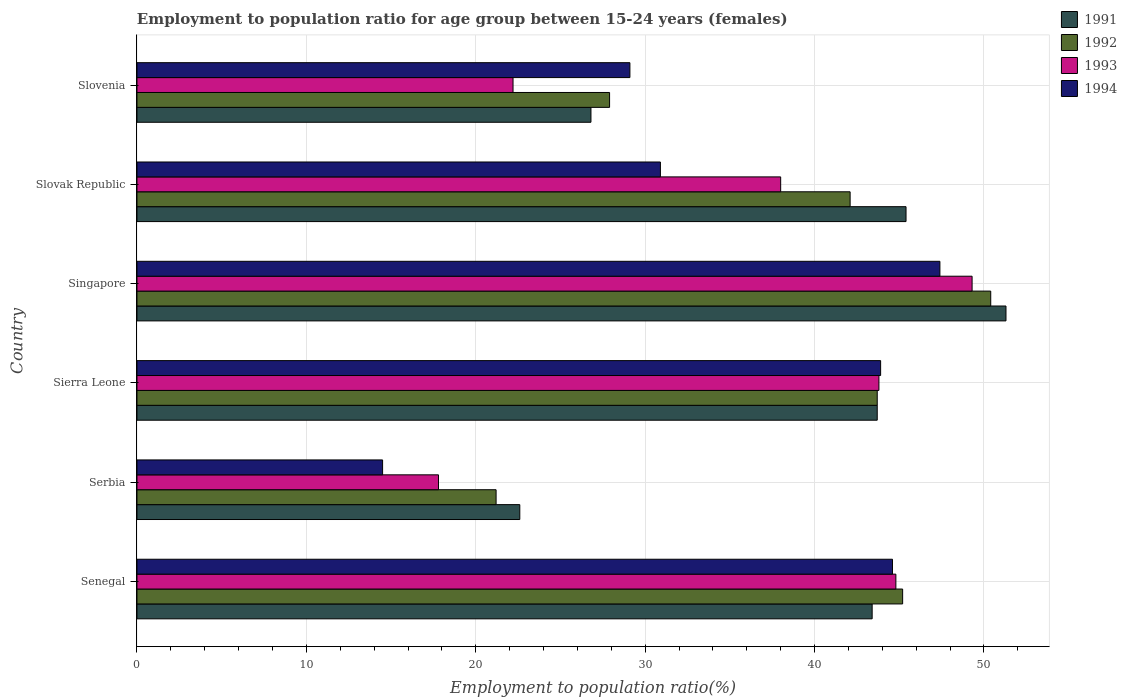How many different coloured bars are there?
Provide a short and direct response. 4. How many groups of bars are there?
Ensure brevity in your answer.  6. How many bars are there on the 1st tick from the top?
Offer a very short reply. 4. What is the label of the 4th group of bars from the top?
Offer a very short reply. Sierra Leone. In how many cases, is the number of bars for a given country not equal to the number of legend labels?
Make the answer very short. 0. What is the employment to population ratio in 1993 in Singapore?
Provide a succinct answer. 49.3. Across all countries, what is the maximum employment to population ratio in 1991?
Your response must be concise. 51.3. Across all countries, what is the minimum employment to population ratio in 1991?
Your answer should be very brief. 22.6. In which country was the employment to population ratio in 1994 maximum?
Offer a very short reply. Singapore. In which country was the employment to population ratio in 1992 minimum?
Offer a terse response. Serbia. What is the total employment to population ratio in 1993 in the graph?
Make the answer very short. 215.9. What is the difference between the employment to population ratio in 1991 in Senegal and that in Serbia?
Offer a very short reply. 20.8. What is the difference between the employment to population ratio in 1992 in Slovenia and the employment to population ratio in 1994 in Slovak Republic?
Keep it short and to the point. -3. What is the average employment to population ratio in 1993 per country?
Give a very brief answer. 35.98. What is the difference between the employment to population ratio in 1994 and employment to population ratio in 1992 in Sierra Leone?
Offer a very short reply. 0.2. In how many countries, is the employment to population ratio in 1991 greater than 16 %?
Give a very brief answer. 6. What is the ratio of the employment to population ratio in 1993 in Senegal to that in Slovak Republic?
Provide a succinct answer. 1.18. What is the difference between the highest and the lowest employment to population ratio in 1994?
Your answer should be very brief. 32.9. In how many countries, is the employment to population ratio in 1991 greater than the average employment to population ratio in 1991 taken over all countries?
Make the answer very short. 4. What does the 1st bar from the top in Slovenia represents?
Give a very brief answer. 1994. What does the 1st bar from the bottom in Slovak Republic represents?
Offer a very short reply. 1991. How many countries are there in the graph?
Ensure brevity in your answer.  6. Are the values on the major ticks of X-axis written in scientific E-notation?
Your response must be concise. No. Does the graph contain grids?
Your answer should be compact. Yes. Where does the legend appear in the graph?
Your answer should be very brief. Top right. What is the title of the graph?
Make the answer very short. Employment to population ratio for age group between 15-24 years (females). What is the label or title of the Y-axis?
Give a very brief answer. Country. What is the Employment to population ratio(%) of 1991 in Senegal?
Ensure brevity in your answer.  43.4. What is the Employment to population ratio(%) in 1992 in Senegal?
Keep it short and to the point. 45.2. What is the Employment to population ratio(%) in 1993 in Senegal?
Offer a very short reply. 44.8. What is the Employment to population ratio(%) of 1994 in Senegal?
Offer a terse response. 44.6. What is the Employment to population ratio(%) in 1991 in Serbia?
Offer a very short reply. 22.6. What is the Employment to population ratio(%) in 1992 in Serbia?
Make the answer very short. 21.2. What is the Employment to population ratio(%) of 1993 in Serbia?
Ensure brevity in your answer.  17.8. What is the Employment to population ratio(%) in 1991 in Sierra Leone?
Provide a short and direct response. 43.7. What is the Employment to population ratio(%) of 1992 in Sierra Leone?
Offer a terse response. 43.7. What is the Employment to population ratio(%) in 1993 in Sierra Leone?
Keep it short and to the point. 43.8. What is the Employment to population ratio(%) of 1994 in Sierra Leone?
Offer a very short reply. 43.9. What is the Employment to population ratio(%) of 1991 in Singapore?
Your answer should be very brief. 51.3. What is the Employment to population ratio(%) of 1992 in Singapore?
Provide a succinct answer. 50.4. What is the Employment to population ratio(%) in 1993 in Singapore?
Your answer should be compact. 49.3. What is the Employment to population ratio(%) of 1994 in Singapore?
Your response must be concise. 47.4. What is the Employment to population ratio(%) of 1991 in Slovak Republic?
Provide a succinct answer. 45.4. What is the Employment to population ratio(%) of 1992 in Slovak Republic?
Offer a very short reply. 42.1. What is the Employment to population ratio(%) of 1994 in Slovak Republic?
Keep it short and to the point. 30.9. What is the Employment to population ratio(%) of 1991 in Slovenia?
Your answer should be compact. 26.8. What is the Employment to population ratio(%) of 1992 in Slovenia?
Your answer should be very brief. 27.9. What is the Employment to population ratio(%) in 1993 in Slovenia?
Your answer should be compact. 22.2. What is the Employment to population ratio(%) in 1994 in Slovenia?
Ensure brevity in your answer.  29.1. Across all countries, what is the maximum Employment to population ratio(%) of 1991?
Offer a terse response. 51.3. Across all countries, what is the maximum Employment to population ratio(%) of 1992?
Provide a succinct answer. 50.4. Across all countries, what is the maximum Employment to population ratio(%) of 1993?
Make the answer very short. 49.3. Across all countries, what is the maximum Employment to population ratio(%) of 1994?
Ensure brevity in your answer.  47.4. Across all countries, what is the minimum Employment to population ratio(%) of 1991?
Your response must be concise. 22.6. Across all countries, what is the minimum Employment to population ratio(%) of 1992?
Your answer should be very brief. 21.2. Across all countries, what is the minimum Employment to population ratio(%) in 1993?
Your response must be concise. 17.8. Across all countries, what is the minimum Employment to population ratio(%) of 1994?
Give a very brief answer. 14.5. What is the total Employment to population ratio(%) in 1991 in the graph?
Your response must be concise. 233.2. What is the total Employment to population ratio(%) in 1992 in the graph?
Provide a short and direct response. 230.5. What is the total Employment to population ratio(%) of 1993 in the graph?
Make the answer very short. 215.9. What is the total Employment to population ratio(%) in 1994 in the graph?
Provide a succinct answer. 210.4. What is the difference between the Employment to population ratio(%) of 1991 in Senegal and that in Serbia?
Your answer should be very brief. 20.8. What is the difference between the Employment to population ratio(%) of 1994 in Senegal and that in Serbia?
Provide a short and direct response. 30.1. What is the difference between the Employment to population ratio(%) in 1991 in Senegal and that in Sierra Leone?
Give a very brief answer. -0.3. What is the difference between the Employment to population ratio(%) in 1992 in Senegal and that in Sierra Leone?
Make the answer very short. 1.5. What is the difference between the Employment to population ratio(%) in 1993 in Senegal and that in Sierra Leone?
Offer a terse response. 1. What is the difference between the Employment to population ratio(%) of 1994 in Senegal and that in Sierra Leone?
Ensure brevity in your answer.  0.7. What is the difference between the Employment to population ratio(%) of 1993 in Senegal and that in Singapore?
Your response must be concise. -4.5. What is the difference between the Employment to population ratio(%) of 1991 in Senegal and that in Slovak Republic?
Your response must be concise. -2. What is the difference between the Employment to population ratio(%) in 1994 in Senegal and that in Slovak Republic?
Provide a short and direct response. 13.7. What is the difference between the Employment to population ratio(%) in 1991 in Senegal and that in Slovenia?
Your response must be concise. 16.6. What is the difference between the Employment to population ratio(%) of 1993 in Senegal and that in Slovenia?
Provide a short and direct response. 22.6. What is the difference between the Employment to population ratio(%) of 1991 in Serbia and that in Sierra Leone?
Give a very brief answer. -21.1. What is the difference between the Employment to population ratio(%) in 1992 in Serbia and that in Sierra Leone?
Offer a very short reply. -22.5. What is the difference between the Employment to population ratio(%) in 1994 in Serbia and that in Sierra Leone?
Ensure brevity in your answer.  -29.4. What is the difference between the Employment to population ratio(%) in 1991 in Serbia and that in Singapore?
Your answer should be compact. -28.7. What is the difference between the Employment to population ratio(%) of 1992 in Serbia and that in Singapore?
Your response must be concise. -29.2. What is the difference between the Employment to population ratio(%) of 1993 in Serbia and that in Singapore?
Give a very brief answer. -31.5. What is the difference between the Employment to population ratio(%) of 1994 in Serbia and that in Singapore?
Your answer should be very brief. -32.9. What is the difference between the Employment to population ratio(%) of 1991 in Serbia and that in Slovak Republic?
Offer a terse response. -22.8. What is the difference between the Employment to population ratio(%) in 1992 in Serbia and that in Slovak Republic?
Make the answer very short. -20.9. What is the difference between the Employment to population ratio(%) of 1993 in Serbia and that in Slovak Republic?
Offer a very short reply. -20.2. What is the difference between the Employment to population ratio(%) of 1994 in Serbia and that in Slovak Republic?
Make the answer very short. -16.4. What is the difference between the Employment to population ratio(%) of 1993 in Serbia and that in Slovenia?
Your answer should be compact. -4.4. What is the difference between the Employment to population ratio(%) of 1994 in Serbia and that in Slovenia?
Ensure brevity in your answer.  -14.6. What is the difference between the Employment to population ratio(%) of 1991 in Sierra Leone and that in Singapore?
Ensure brevity in your answer.  -7.6. What is the difference between the Employment to population ratio(%) of 1993 in Sierra Leone and that in Singapore?
Offer a terse response. -5.5. What is the difference between the Employment to population ratio(%) of 1992 in Sierra Leone and that in Slovak Republic?
Your answer should be compact. 1.6. What is the difference between the Employment to population ratio(%) in 1993 in Sierra Leone and that in Slovak Republic?
Your response must be concise. 5.8. What is the difference between the Employment to population ratio(%) of 1992 in Sierra Leone and that in Slovenia?
Your answer should be compact. 15.8. What is the difference between the Employment to population ratio(%) of 1993 in Sierra Leone and that in Slovenia?
Offer a very short reply. 21.6. What is the difference between the Employment to population ratio(%) in 1991 in Singapore and that in Slovak Republic?
Offer a very short reply. 5.9. What is the difference between the Employment to population ratio(%) in 1994 in Singapore and that in Slovak Republic?
Ensure brevity in your answer.  16.5. What is the difference between the Employment to population ratio(%) of 1993 in Singapore and that in Slovenia?
Ensure brevity in your answer.  27.1. What is the difference between the Employment to population ratio(%) in 1994 in Singapore and that in Slovenia?
Your answer should be compact. 18.3. What is the difference between the Employment to population ratio(%) in 1993 in Slovak Republic and that in Slovenia?
Give a very brief answer. 15.8. What is the difference between the Employment to population ratio(%) in 1991 in Senegal and the Employment to population ratio(%) in 1993 in Serbia?
Ensure brevity in your answer.  25.6. What is the difference between the Employment to population ratio(%) in 1991 in Senegal and the Employment to population ratio(%) in 1994 in Serbia?
Your answer should be compact. 28.9. What is the difference between the Employment to population ratio(%) in 1992 in Senegal and the Employment to population ratio(%) in 1993 in Serbia?
Your answer should be compact. 27.4. What is the difference between the Employment to population ratio(%) in 1992 in Senegal and the Employment to population ratio(%) in 1994 in Serbia?
Your response must be concise. 30.7. What is the difference between the Employment to population ratio(%) in 1993 in Senegal and the Employment to population ratio(%) in 1994 in Serbia?
Ensure brevity in your answer.  30.3. What is the difference between the Employment to population ratio(%) in 1992 in Senegal and the Employment to population ratio(%) in 1994 in Sierra Leone?
Provide a succinct answer. 1.3. What is the difference between the Employment to population ratio(%) of 1992 in Senegal and the Employment to population ratio(%) of 1993 in Singapore?
Your answer should be compact. -4.1. What is the difference between the Employment to population ratio(%) of 1993 in Senegal and the Employment to population ratio(%) of 1994 in Singapore?
Keep it short and to the point. -2.6. What is the difference between the Employment to population ratio(%) in 1991 in Senegal and the Employment to population ratio(%) in 1992 in Slovak Republic?
Provide a succinct answer. 1.3. What is the difference between the Employment to population ratio(%) in 1991 in Senegal and the Employment to population ratio(%) in 1994 in Slovak Republic?
Provide a succinct answer. 12.5. What is the difference between the Employment to population ratio(%) in 1991 in Senegal and the Employment to population ratio(%) in 1993 in Slovenia?
Your answer should be very brief. 21.2. What is the difference between the Employment to population ratio(%) in 1991 in Senegal and the Employment to population ratio(%) in 1994 in Slovenia?
Provide a short and direct response. 14.3. What is the difference between the Employment to population ratio(%) in 1992 in Senegal and the Employment to population ratio(%) in 1993 in Slovenia?
Your answer should be compact. 23. What is the difference between the Employment to population ratio(%) in 1992 in Senegal and the Employment to population ratio(%) in 1994 in Slovenia?
Your response must be concise. 16.1. What is the difference between the Employment to population ratio(%) of 1991 in Serbia and the Employment to population ratio(%) of 1992 in Sierra Leone?
Provide a short and direct response. -21.1. What is the difference between the Employment to population ratio(%) in 1991 in Serbia and the Employment to population ratio(%) in 1993 in Sierra Leone?
Keep it short and to the point. -21.2. What is the difference between the Employment to population ratio(%) in 1991 in Serbia and the Employment to population ratio(%) in 1994 in Sierra Leone?
Keep it short and to the point. -21.3. What is the difference between the Employment to population ratio(%) of 1992 in Serbia and the Employment to population ratio(%) of 1993 in Sierra Leone?
Offer a very short reply. -22.6. What is the difference between the Employment to population ratio(%) of 1992 in Serbia and the Employment to population ratio(%) of 1994 in Sierra Leone?
Your response must be concise. -22.7. What is the difference between the Employment to population ratio(%) in 1993 in Serbia and the Employment to population ratio(%) in 1994 in Sierra Leone?
Your answer should be very brief. -26.1. What is the difference between the Employment to population ratio(%) of 1991 in Serbia and the Employment to population ratio(%) of 1992 in Singapore?
Offer a very short reply. -27.8. What is the difference between the Employment to population ratio(%) in 1991 in Serbia and the Employment to population ratio(%) in 1993 in Singapore?
Offer a very short reply. -26.7. What is the difference between the Employment to population ratio(%) of 1991 in Serbia and the Employment to population ratio(%) of 1994 in Singapore?
Provide a short and direct response. -24.8. What is the difference between the Employment to population ratio(%) of 1992 in Serbia and the Employment to population ratio(%) of 1993 in Singapore?
Make the answer very short. -28.1. What is the difference between the Employment to population ratio(%) of 1992 in Serbia and the Employment to population ratio(%) of 1994 in Singapore?
Your answer should be very brief. -26.2. What is the difference between the Employment to population ratio(%) of 1993 in Serbia and the Employment to population ratio(%) of 1994 in Singapore?
Your answer should be very brief. -29.6. What is the difference between the Employment to population ratio(%) in 1991 in Serbia and the Employment to population ratio(%) in 1992 in Slovak Republic?
Offer a very short reply. -19.5. What is the difference between the Employment to population ratio(%) of 1991 in Serbia and the Employment to population ratio(%) of 1993 in Slovak Republic?
Provide a succinct answer. -15.4. What is the difference between the Employment to population ratio(%) in 1991 in Serbia and the Employment to population ratio(%) in 1994 in Slovak Republic?
Your answer should be compact. -8.3. What is the difference between the Employment to population ratio(%) in 1992 in Serbia and the Employment to population ratio(%) in 1993 in Slovak Republic?
Offer a very short reply. -16.8. What is the difference between the Employment to population ratio(%) of 1992 in Serbia and the Employment to population ratio(%) of 1993 in Slovenia?
Make the answer very short. -1. What is the difference between the Employment to population ratio(%) of 1993 in Serbia and the Employment to population ratio(%) of 1994 in Slovenia?
Provide a short and direct response. -11.3. What is the difference between the Employment to population ratio(%) of 1991 in Sierra Leone and the Employment to population ratio(%) of 1992 in Singapore?
Offer a very short reply. -6.7. What is the difference between the Employment to population ratio(%) of 1992 in Sierra Leone and the Employment to population ratio(%) of 1993 in Singapore?
Offer a very short reply. -5.6. What is the difference between the Employment to population ratio(%) of 1993 in Sierra Leone and the Employment to population ratio(%) of 1994 in Singapore?
Offer a terse response. -3.6. What is the difference between the Employment to population ratio(%) in 1991 in Sierra Leone and the Employment to population ratio(%) in 1994 in Slovak Republic?
Give a very brief answer. 12.8. What is the difference between the Employment to population ratio(%) of 1991 in Sierra Leone and the Employment to population ratio(%) of 1994 in Slovenia?
Your answer should be compact. 14.6. What is the difference between the Employment to population ratio(%) in 1993 in Sierra Leone and the Employment to population ratio(%) in 1994 in Slovenia?
Offer a terse response. 14.7. What is the difference between the Employment to population ratio(%) of 1991 in Singapore and the Employment to population ratio(%) of 1993 in Slovak Republic?
Provide a short and direct response. 13.3. What is the difference between the Employment to population ratio(%) of 1991 in Singapore and the Employment to population ratio(%) of 1994 in Slovak Republic?
Provide a short and direct response. 20.4. What is the difference between the Employment to population ratio(%) in 1991 in Singapore and the Employment to population ratio(%) in 1992 in Slovenia?
Provide a short and direct response. 23.4. What is the difference between the Employment to population ratio(%) of 1991 in Singapore and the Employment to population ratio(%) of 1993 in Slovenia?
Make the answer very short. 29.1. What is the difference between the Employment to population ratio(%) in 1991 in Singapore and the Employment to population ratio(%) in 1994 in Slovenia?
Make the answer very short. 22.2. What is the difference between the Employment to population ratio(%) in 1992 in Singapore and the Employment to population ratio(%) in 1993 in Slovenia?
Make the answer very short. 28.2. What is the difference between the Employment to population ratio(%) of 1992 in Singapore and the Employment to population ratio(%) of 1994 in Slovenia?
Your answer should be very brief. 21.3. What is the difference between the Employment to population ratio(%) of 1993 in Singapore and the Employment to population ratio(%) of 1994 in Slovenia?
Provide a short and direct response. 20.2. What is the difference between the Employment to population ratio(%) of 1991 in Slovak Republic and the Employment to population ratio(%) of 1993 in Slovenia?
Offer a very short reply. 23.2. What is the difference between the Employment to population ratio(%) in 1992 in Slovak Republic and the Employment to population ratio(%) in 1993 in Slovenia?
Give a very brief answer. 19.9. What is the average Employment to population ratio(%) in 1991 per country?
Offer a very short reply. 38.87. What is the average Employment to population ratio(%) in 1992 per country?
Make the answer very short. 38.42. What is the average Employment to population ratio(%) in 1993 per country?
Provide a succinct answer. 35.98. What is the average Employment to population ratio(%) in 1994 per country?
Provide a short and direct response. 35.07. What is the difference between the Employment to population ratio(%) in 1991 and Employment to population ratio(%) in 1993 in Senegal?
Your response must be concise. -1.4. What is the difference between the Employment to population ratio(%) in 1991 and Employment to population ratio(%) in 1994 in Senegal?
Your answer should be compact. -1.2. What is the difference between the Employment to population ratio(%) of 1993 and Employment to population ratio(%) of 1994 in Senegal?
Give a very brief answer. 0.2. What is the difference between the Employment to population ratio(%) in 1991 and Employment to population ratio(%) in 1992 in Serbia?
Your answer should be compact. 1.4. What is the difference between the Employment to population ratio(%) of 1991 and Employment to population ratio(%) of 1993 in Serbia?
Provide a succinct answer. 4.8. What is the difference between the Employment to population ratio(%) of 1991 and Employment to population ratio(%) of 1994 in Serbia?
Your answer should be compact. 8.1. What is the difference between the Employment to population ratio(%) of 1992 and Employment to population ratio(%) of 1993 in Sierra Leone?
Keep it short and to the point. -0.1. What is the difference between the Employment to population ratio(%) in 1991 and Employment to population ratio(%) in 1994 in Singapore?
Ensure brevity in your answer.  3.9. What is the difference between the Employment to population ratio(%) of 1992 and Employment to population ratio(%) of 1993 in Singapore?
Give a very brief answer. 1.1. What is the difference between the Employment to population ratio(%) in 1992 and Employment to population ratio(%) in 1994 in Singapore?
Your response must be concise. 3. What is the difference between the Employment to population ratio(%) in 1991 and Employment to population ratio(%) in 1992 in Slovak Republic?
Keep it short and to the point. 3.3. What is the difference between the Employment to population ratio(%) of 1992 and Employment to population ratio(%) of 1993 in Slovak Republic?
Give a very brief answer. 4.1. What is the difference between the Employment to population ratio(%) of 1992 and Employment to population ratio(%) of 1994 in Slovak Republic?
Offer a very short reply. 11.2. What is the difference between the Employment to population ratio(%) of 1993 and Employment to population ratio(%) of 1994 in Slovak Republic?
Keep it short and to the point. 7.1. What is the difference between the Employment to population ratio(%) in 1991 and Employment to population ratio(%) in 1992 in Slovenia?
Your response must be concise. -1.1. What is the difference between the Employment to population ratio(%) of 1991 and Employment to population ratio(%) of 1994 in Slovenia?
Offer a very short reply. -2.3. What is the difference between the Employment to population ratio(%) in 1993 and Employment to population ratio(%) in 1994 in Slovenia?
Your answer should be very brief. -6.9. What is the ratio of the Employment to population ratio(%) in 1991 in Senegal to that in Serbia?
Your response must be concise. 1.92. What is the ratio of the Employment to population ratio(%) in 1992 in Senegal to that in Serbia?
Your response must be concise. 2.13. What is the ratio of the Employment to population ratio(%) of 1993 in Senegal to that in Serbia?
Provide a succinct answer. 2.52. What is the ratio of the Employment to population ratio(%) of 1994 in Senegal to that in Serbia?
Offer a very short reply. 3.08. What is the ratio of the Employment to population ratio(%) in 1992 in Senegal to that in Sierra Leone?
Ensure brevity in your answer.  1.03. What is the ratio of the Employment to population ratio(%) of 1993 in Senegal to that in Sierra Leone?
Make the answer very short. 1.02. What is the ratio of the Employment to population ratio(%) of 1994 in Senegal to that in Sierra Leone?
Make the answer very short. 1.02. What is the ratio of the Employment to population ratio(%) of 1991 in Senegal to that in Singapore?
Your answer should be very brief. 0.85. What is the ratio of the Employment to population ratio(%) in 1992 in Senegal to that in Singapore?
Make the answer very short. 0.9. What is the ratio of the Employment to population ratio(%) in 1993 in Senegal to that in Singapore?
Your answer should be very brief. 0.91. What is the ratio of the Employment to population ratio(%) in 1994 in Senegal to that in Singapore?
Your answer should be compact. 0.94. What is the ratio of the Employment to population ratio(%) of 1991 in Senegal to that in Slovak Republic?
Provide a short and direct response. 0.96. What is the ratio of the Employment to population ratio(%) of 1992 in Senegal to that in Slovak Republic?
Keep it short and to the point. 1.07. What is the ratio of the Employment to population ratio(%) of 1993 in Senegal to that in Slovak Republic?
Offer a very short reply. 1.18. What is the ratio of the Employment to population ratio(%) in 1994 in Senegal to that in Slovak Republic?
Ensure brevity in your answer.  1.44. What is the ratio of the Employment to population ratio(%) in 1991 in Senegal to that in Slovenia?
Ensure brevity in your answer.  1.62. What is the ratio of the Employment to population ratio(%) of 1992 in Senegal to that in Slovenia?
Ensure brevity in your answer.  1.62. What is the ratio of the Employment to population ratio(%) of 1993 in Senegal to that in Slovenia?
Offer a very short reply. 2.02. What is the ratio of the Employment to population ratio(%) in 1994 in Senegal to that in Slovenia?
Offer a terse response. 1.53. What is the ratio of the Employment to population ratio(%) of 1991 in Serbia to that in Sierra Leone?
Offer a very short reply. 0.52. What is the ratio of the Employment to population ratio(%) in 1992 in Serbia to that in Sierra Leone?
Your answer should be compact. 0.49. What is the ratio of the Employment to population ratio(%) in 1993 in Serbia to that in Sierra Leone?
Provide a succinct answer. 0.41. What is the ratio of the Employment to population ratio(%) of 1994 in Serbia to that in Sierra Leone?
Offer a terse response. 0.33. What is the ratio of the Employment to population ratio(%) in 1991 in Serbia to that in Singapore?
Offer a terse response. 0.44. What is the ratio of the Employment to population ratio(%) in 1992 in Serbia to that in Singapore?
Keep it short and to the point. 0.42. What is the ratio of the Employment to population ratio(%) of 1993 in Serbia to that in Singapore?
Offer a very short reply. 0.36. What is the ratio of the Employment to population ratio(%) in 1994 in Serbia to that in Singapore?
Offer a very short reply. 0.31. What is the ratio of the Employment to population ratio(%) in 1991 in Serbia to that in Slovak Republic?
Provide a short and direct response. 0.5. What is the ratio of the Employment to population ratio(%) of 1992 in Serbia to that in Slovak Republic?
Make the answer very short. 0.5. What is the ratio of the Employment to population ratio(%) in 1993 in Serbia to that in Slovak Republic?
Provide a succinct answer. 0.47. What is the ratio of the Employment to population ratio(%) of 1994 in Serbia to that in Slovak Republic?
Provide a succinct answer. 0.47. What is the ratio of the Employment to population ratio(%) of 1991 in Serbia to that in Slovenia?
Give a very brief answer. 0.84. What is the ratio of the Employment to population ratio(%) of 1992 in Serbia to that in Slovenia?
Provide a succinct answer. 0.76. What is the ratio of the Employment to population ratio(%) in 1993 in Serbia to that in Slovenia?
Your answer should be very brief. 0.8. What is the ratio of the Employment to population ratio(%) in 1994 in Serbia to that in Slovenia?
Provide a short and direct response. 0.5. What is the ratio of the Employment to population ratio(%) of 1991 in Sierra Leone to that in Singapore?
Offer a very short reply. 0.85. What is the ratio of the Employment to population ratio(%) of 1992 in Sierra Leone to that in Singapore?
Make the answer very short. 0.87. What is the ratio of the Employment to population ratio(%) in 1993 in Sierra Leone to that in Singapore?
Provide a succinct answer. 0.89. What is the ratio of the Employment to population ratio(%) of 1994 in Sierra Leone to that in Singapore?
Keep it short and to the point. 0.93. What is the ratio of the Employment to population ratio(%) in 1991 in Sierra Leone to that in Slovak Republic?
Give a very brief answer. 0.96. What is the ratio of the Employment to population ratio(%) in 1992 in Sierra Leone to that in Slovak Republic?
Ensure brevity in your answer.  1.04. What is the ratio of the Employment to population ratio(%) in 1993 in Sierra Leone to that in Slovak Republic?
Offer a very short reply. 1.15. What is the ratio of the Employment to population ratio(%) of 1994 in Sierra Leone to that in Slovak Republic?
Make the answer very short. 1.42. What is the ratio of the Employment to population ratio(%) in 1991 in Sierra Leone to that in Slovenia?
Offer a very short reply. 1.63. What is the ratio of the Employment to population ratio(%) in 1992 in Sierra Leone to that in Slovenia?
Your answer should be very brief. 1.57. What is the ratio of the Employment to population ratio(%) in 1993 in Sierra Leone to that in Slovenia?
Make the answer very short. 1.97. What is the ratio of the Employment to population ratio(%) in 1994 in Sierra Leone to that in Slovenia?
Ensure brevity in your answer.  1.51. What is the ratio of the Employment to population ratio(%) in 1991 in Singapore to that in Slovak Republic?
Offer a very short reply. 1.13. What is the ratio of the Employment to population ratio(%) in 1992 in Singapore to that in Slovak Republic?
Keep it short and to the point. 1.2. What is the ratio of the Employment to population ratio(%) in 1993 in Singapore to that in Slovak Republic?
Your answer should be very brief. 1.3. What is the ratio of the Employment to population ratio(%) in 1994 in Singapore to that in Slovak Republic?
Offer a terse response. 1.53. What is the ratio of the Employment to population ratio(%) in 1991 in Singapore to that in Slovenia?
Make the answer very short. 1.91. What is the ratio of the Employment to population ratio(%) in 1992 in Singapore to that in Slovenia?
Your answer should be very brief. 1.81. What is the ratio of the Employment to population ratio(%) of 1993 in Singapore to that in Slovenia?
Your response must be concise. 2.22. What is the ratio of the Employment to population ratio(%) of 1994 in Singapore to that in Slovenia?
Your response must be concise. 1.63. What is the ratio of the Employment to population ratio(%) of 1991 in Slovak Republic to that in Slovenia?
Make the answer very short. 1.69. What is the ratio of the Employment to population ratio(%) of 1992 in Slovak Republic to that in Slovenia?
Keep it short and to the point. 1.51. What is the ratio of the Employment to population ratio(%) of 1993 in Slovak Republic to that in Slovenia?
Offer a very short reply. 1.71. What is the ratio of the Employment to population ratio(%) of 1994 in Slovak Republic to that in Slovenia?
Give a very brief answer. 1.06. What is the difference between the highest and the second highest Employment to population ratio(%) of 1992?
Give a very brief answer. 5.2. What is the difference between the highest and the second highest Employment to population ratio(%) of 1993?
Your response must be concise. 4.5. What is the difference between the highest and the second highest Employment to population ratio(%) in 1994?
Give a very brief answer. 2.8. What is the difference between the highest and the lowest Employment to population ratio(%) of 1991?
Your answer should be very brief. 28.7. What is the difference between the highest and the lowest Employment to population ratio(%) in 1992?
Offer a very short reply. 29.2. What is the difference between the highest and the lowest Employment to population ratio(%) in 1993?
Give a very brief answer. 31.5. What is the difference between the highest and the lowest Employment to population ratio(%) of 1994?
Keep it short and to the point. 32.9. 